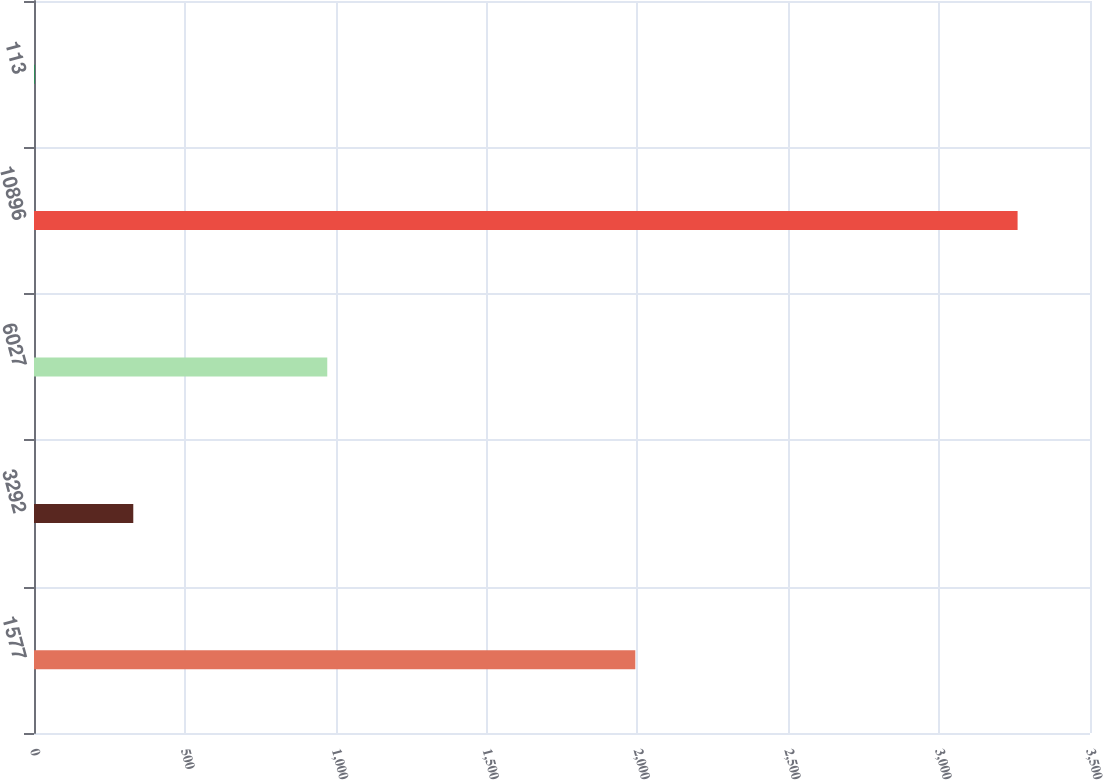<chart> <loc_0><loc_0><loc_500><loc_500><bar_chart><fcel>1577<fcel>3292<fcel>6027<fcel>10896<fcel>113<nl><fcel>1993<fcel>329.06<fcel>972<fcel>3260<fcel>3.4<nl></chart> 